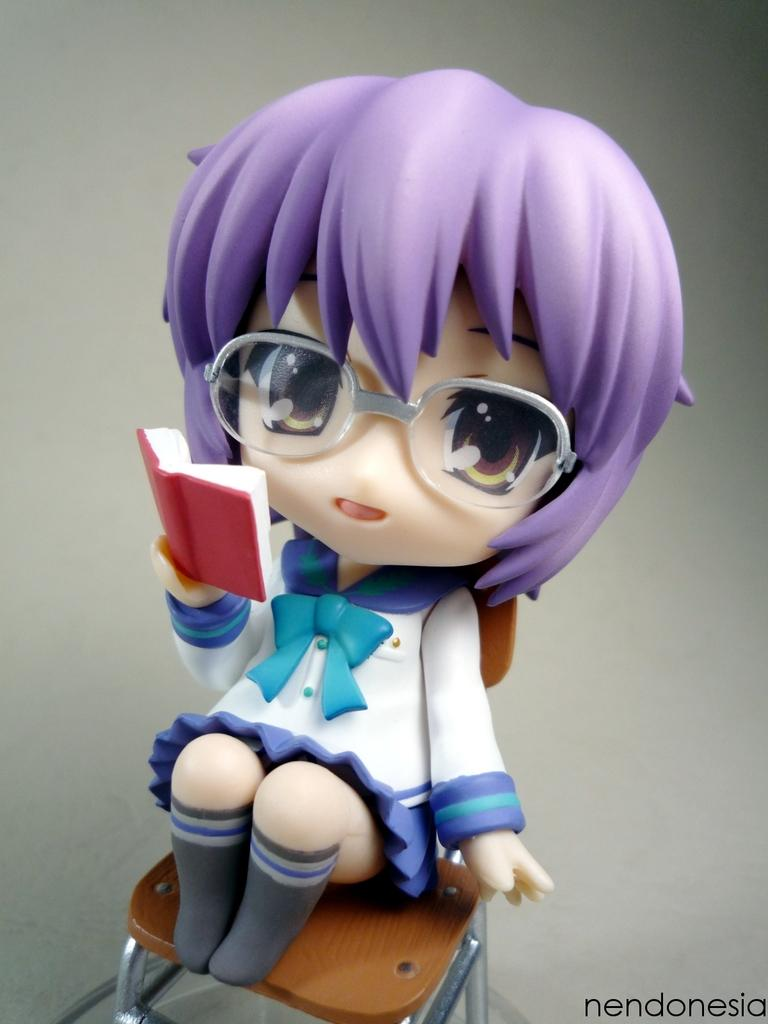What is the main subject of the image? There is a toy doll in the image. Where is the toy doll located in the image? The toy doll is in the center of the image. What is the toy doll sitting on? The toy doll is on a chair. What is the toy doll holding? The toy doll is holding a book. What type of string is attached to the toy doll's arm in the image? There is no string attached to the toy doll's arm in the image. 